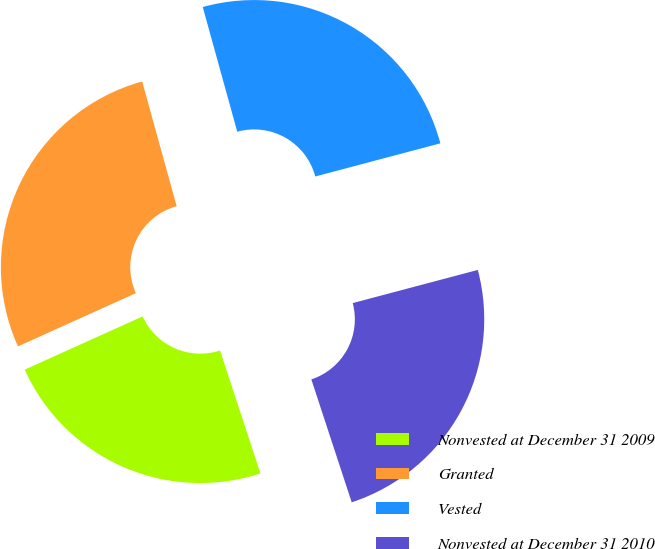<chart> <loc_0><loc_0><loc_500><loc_500><pie_chart><fcel>Nonvested at December 31 2009<fcel>Granted<fcel>Vested<fcel>Nonvested at December 31 2010<nl><fcel>23.3%<fcel>27.45%<fcel>25.17%<fcel>24.07%<nl></chart> 